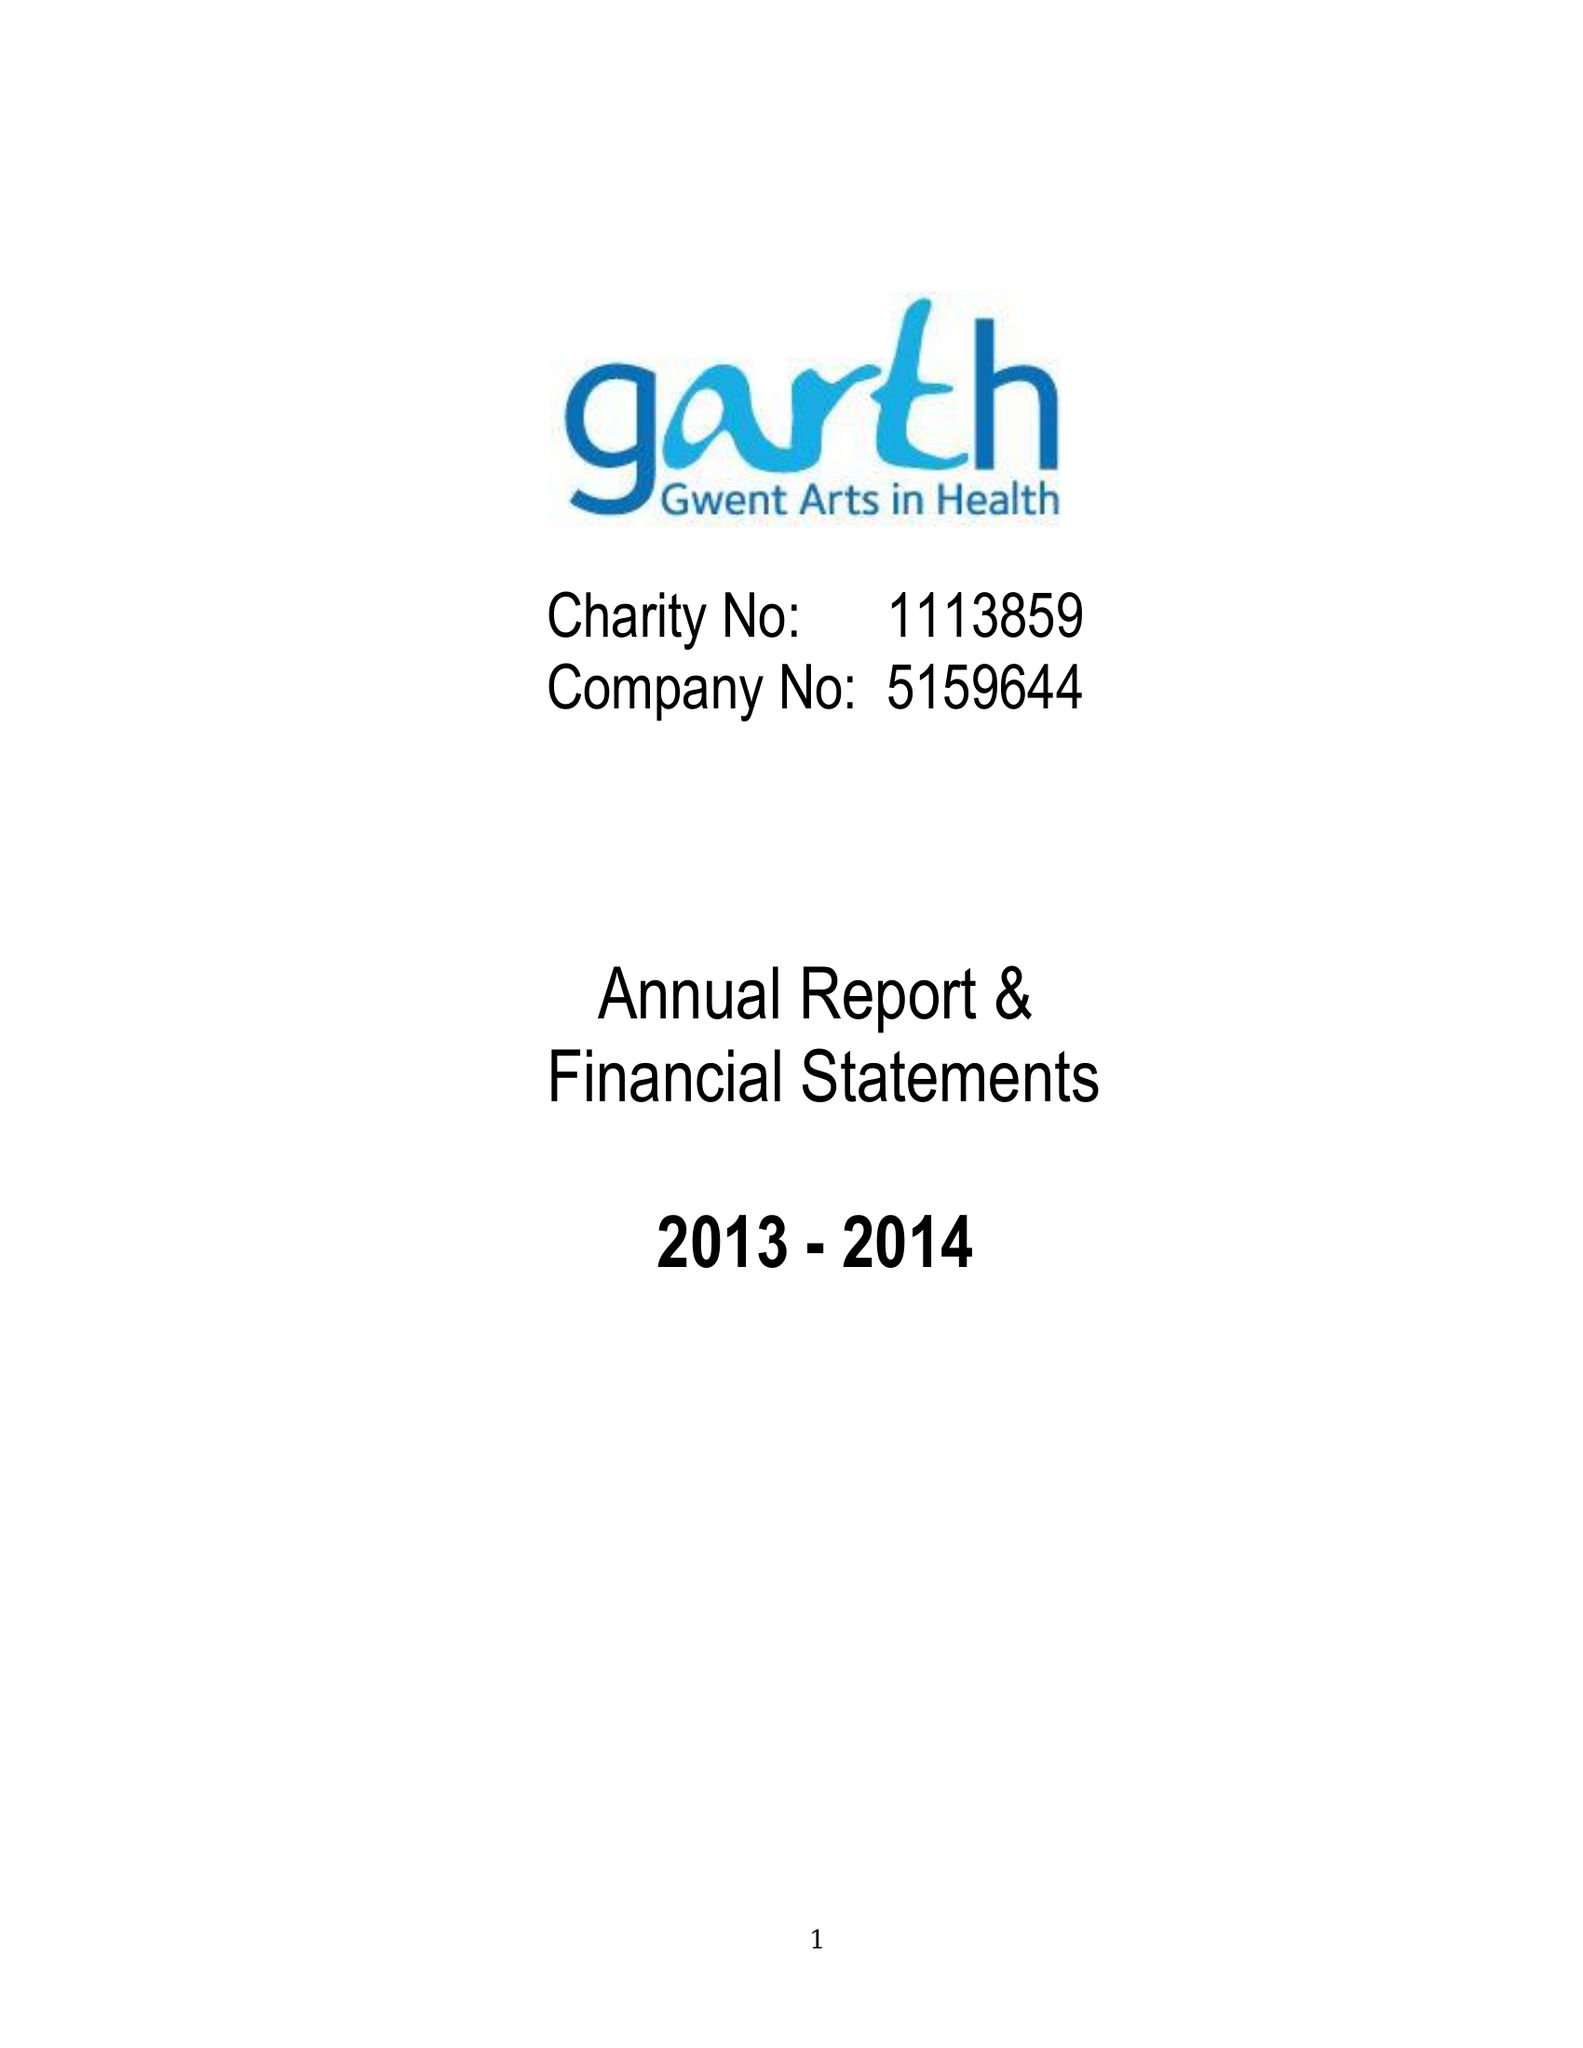What is the value for the charity_number?
Answer the question using a single word or phrase. 1113859 